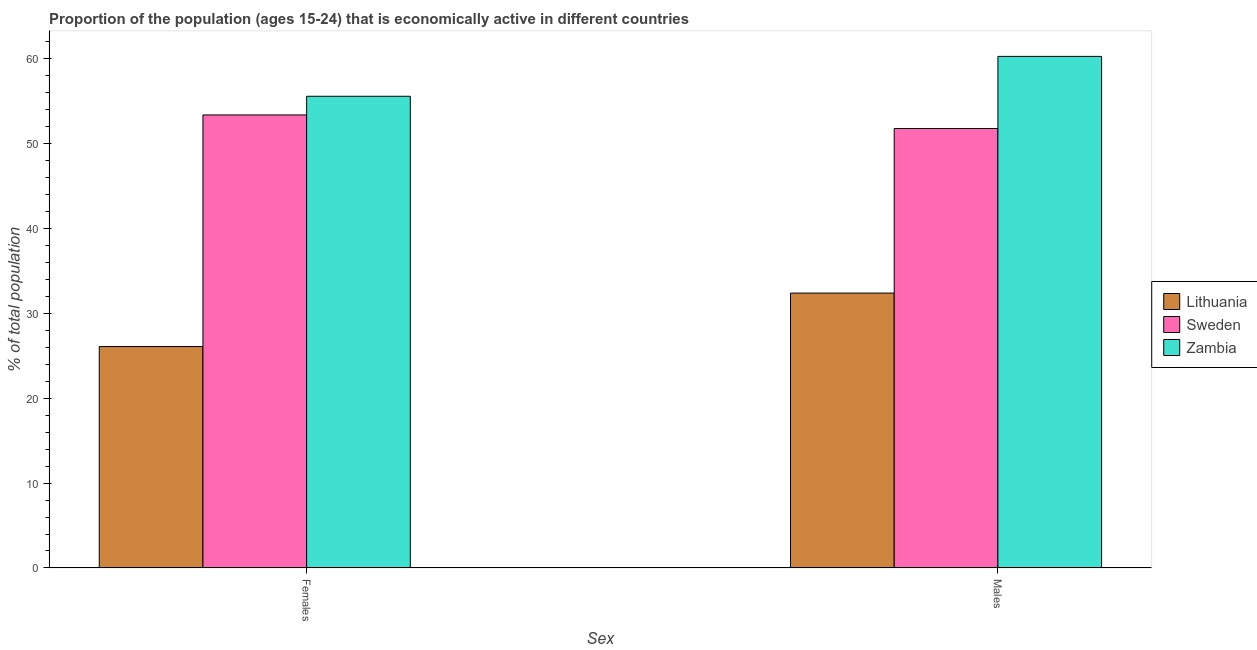How many different coloured bars are there?
Keep it short and to the point. 3. Are the number of bars on each tick of the X-axis equal?
Your response must be concise. Yes. What is the label of the 1st group of bars from the left?
Offer a terse response. Females. What is the percentage of economically active male population in Sweden?
Give a very brief answer. 51.8. Across all countries, what is the maximum percentage of economically active female population?
Your answer should be very brief. 55.6. Across all countries, what is the minimum percentage of economically active male population?
Provide a short and direct response. 32.4. In which country was the percentage of economically active female population maximum?
Your answer should be compact. Zambia. In which country was the percentage of economically active female population minimum?
Keep it short and to the point. Lithuania. What is the total percentage of economically active female population in the graph?
Your answer should be very brief. 135.1. What is the difference between the percentage of economically active female population in Zambia and that in Sweden?
Offer a terse response. 2.2. What is the difference between the percentage of economically active female population in Zambia and the percentage of economically active male population in Sweden?
Keep it short and to the point. 3.8. What is the average percentage of economically active male population per country?
Keep it short and to the point. 48.17. What is the difference between the percentage of economically active female population and percentage of economically active male population in Lithuania?
Make the answer very short. -6.3. What is the ratio of the percentage of economically active male population in Sweden to that in Lithuania?
Your response must be concise. 1.6. Is the percentage of economically active female population in Lithuania less than that in Sweden?
Your answer should be very brief. Yes. In how many countries, is the percentage of economically active male population greater than the average percentage of economically active male population taken over all countries?
Offer a terse response. 2. What does the 3rd bar from the left in Males represents?
Keep it short and to the point. Zambia. What does the 3rd bar from the right in Males represents?
Your answer should be compact. Lithuania. How many bars are there?
Offer a very short reply. 6. Are all the bars in the graph horizontal?
Your answer should be very brief. No. How many countries are there in the graph?
Provide a short and direct response. 3. Does the graph contain any zero values?
Offer a very short reply. No. How many legend labels are there?
Offer a very short reply. 3. What is the title of the graph?
Provide a short and direct response. Proportion of the population (ages 15-24) that is economically active in different countries. What is the label or title of the X-axis?
Ensure brevity in your answer.  Sex. What is the label or title of the Y-axis?
Offer a terse response. % of total population. What is the % of total population in Lithuania in Females?
Make the answer very short. 26.1. What is the % of total population in Sweden in Females?
Ensure brevity in your answer.  53.4. What is the % of total population of Zambia in Females?
Your answer should be compact. 55.6. What is the % of total population in Lithuania in Males?
Give a very brief answer. 32.4. What is the % of total population of Sweden in Males?
Offer a terse response. 51.8. What is the % of total population in Zambia in Males?
Give a very brief answer. 60.3. Across all Sex, what is the maximum % of total population in Lithuania?
Offer a terse response. 32.4. Across all Sex, what is the maximum % of total population in Sweden?
Give a very brief answer. 53.4. Across all Sex, what is the maximum % of total population of Zambia?
Offer a terse response. 60.3. Across all Sex, what is the minimum % of total population in Lithuania?
Make the answer very short. 26.1. Across all Sex, what is the minimum % of total population in Sweden?
Your answer should be compact. 51.8. Across all Sex, what is the minimum % of total population in Zambia?
Provide a succinct answer. 55.6. What is the total % of total population of Lithuania in the graph?
Make the answer very short. 58.5. What is the total % of total population in Sweden in the graph?
Provide a succinct answer. 105.2. What is the total % of total population in Zambia in the graph?
Ensure brevity in your answer.  115.9. What is the difference between the % of total population of Lithuania in Females and that in Males?
Your answer should be compact. -6.3. What is the difference between the % of total population in Zambia in Females and that in Males?
Provide a short and direct response. -4.7. What is the difference between the % of total population in Lithuania in Females and the % of total population in Sweden in Males?
Your answer should be compact. -25.7. What is the difference between the % of total population of Lithuania in Females and the % of total population of Zambia in Males?
Offer a terse response. -34.2. What is the difference between the % of total population of Sweden in Females and the % of total population of Zambia in Males?
Give a very brief answer. -6.9. What is the average % of total population in Lithuania per Sex?
Your response must be concise. 29.25. What is the average % of total population of Sweden per Sex?
Provide a succinct answer. 52.6. What is the average % of total population of Zambia per Sex?
Ensure brevity in your answer.  57.95. What is the difference between the % of total population in Lithuania and % of total population in Sweden in Females?
Ensure brevity in your answer.  -27.3. What is the difference between the % of total population of Lithuania and % of total population of Zambia in Females?
Your response must be concise. -29.5. What is the difference between the % of total population in Lithuania and % of total population in Sweden in Males?
Offer a terse response. -19.4. What is the difference between the % of total population in Lithuania and % of total population in Zambia in Males?
Offer a terse response. -27.9. What is the ratio of the % of total population of Lithuania in Females to that in Males?
Your answer should be compact. 0.81. What is the ratio of the % of total population in Sweden in Females to that in Males?
Offer a terse response. 1.03. What is the ratio of the % of total population of Zambia in Females to that in Males?
Offer a very short reply. 0.92. What is the difference between the highest and the second highest % of total population in Lithuania?
Offer a very short reply. 6.3. What is the difference between the highest and the lowest % of total population in Lithuania?
Provide a succinct answer. 6.3. 